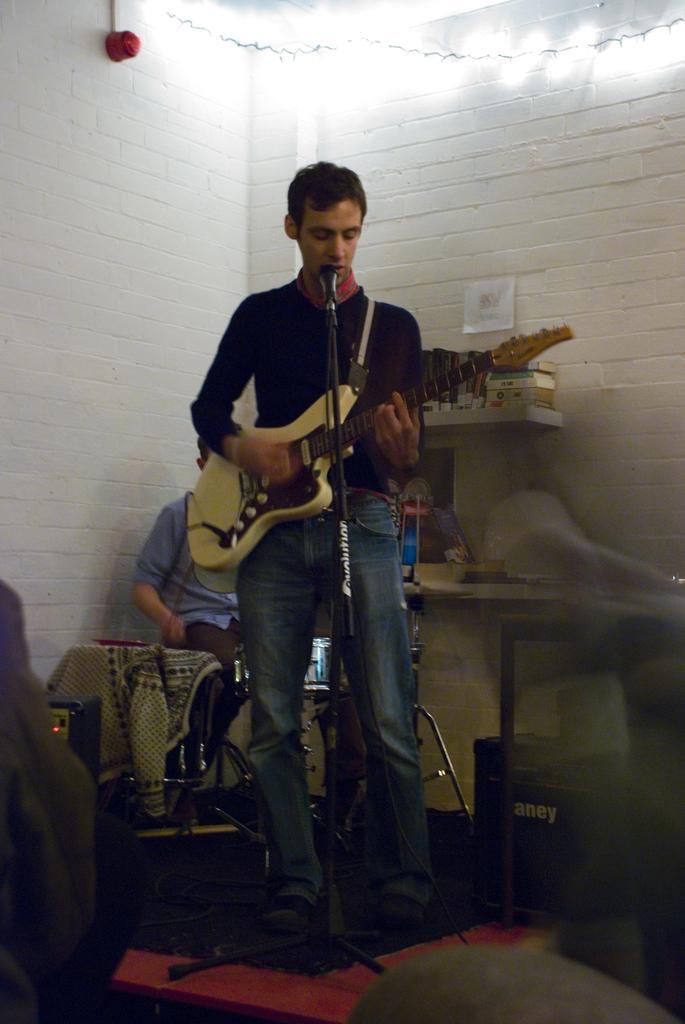Please provide a concise description of this image. This picture is taken in a room, There is a man standing in the middle and holding a music instrument which is in yellow color and there is a microphone in black color, In the background there is a white color wall and there are some lights on the top. 